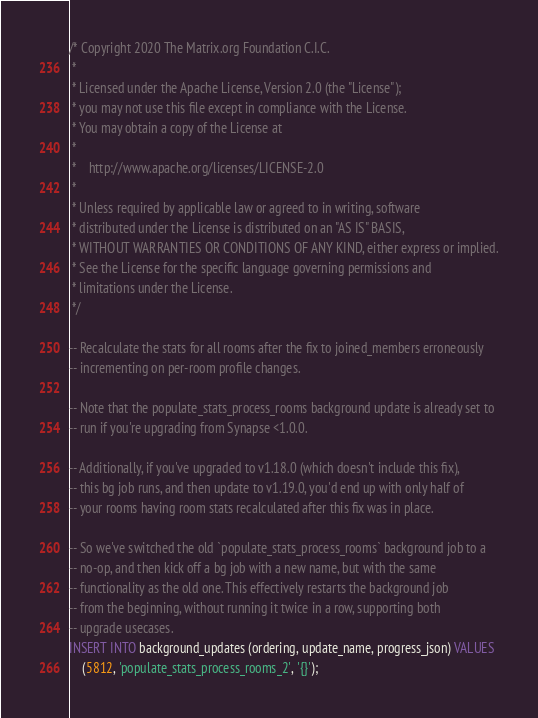<code> <loc_0><loc_0><loc_500><loc_500><_SQL_>/* Copyright 2020 The Matrix.org Foundation C.I.C.
 *
 * Licensed under the Apache License, Version 2.0 (the "License");
 * you may not use this file except in compliance with the License.
 * You may obtain a copy of the License at
 *
 *    http://www.apache.org/licenses/LICENSE-2.0
 *
 * Unless required by applicable law or agreed to in writing, software
 * distributed under the License is distributed on an "AS IS" BASIS,
 * WITHOUT WARRANTIES OR CONDITIONS OF ANY KIND, either express or implied.
 * See the License for the specific language governing permissions and
 * limitations under the License.
 */

-- Recalculate the stats for all rooms after the fix to joined_members erroneously
-- incrementing on per-room profile changes.

-- Note that the populate_stats_process_rooms background update is already set to
-- run if you're upgrading from Synapse <1.0.0.

-- Additionally, if you've upgraded to v1.18.0 (which doesn't include this fix),
-- this bg job runs, and then update to v1.19.0, you'd end up with only half of
-- your rooms having room stats recalculated after this fix was in place.

-- So we've switched the old `populate_stats_process_rooms` background job to a
-- no-op, and then kick off a bg job with a new name, but with the same
-- functionality as the old one. This effectively restarts the background job
-- from the beginning, without running it twice in a row, supporting both
-- upgrade usecases.
INSERT INTO background_updates (ordering, update_name, progress_json) VALUES
    (5812, 'populate_stats_process_rooms_2', '{}');
</code> 